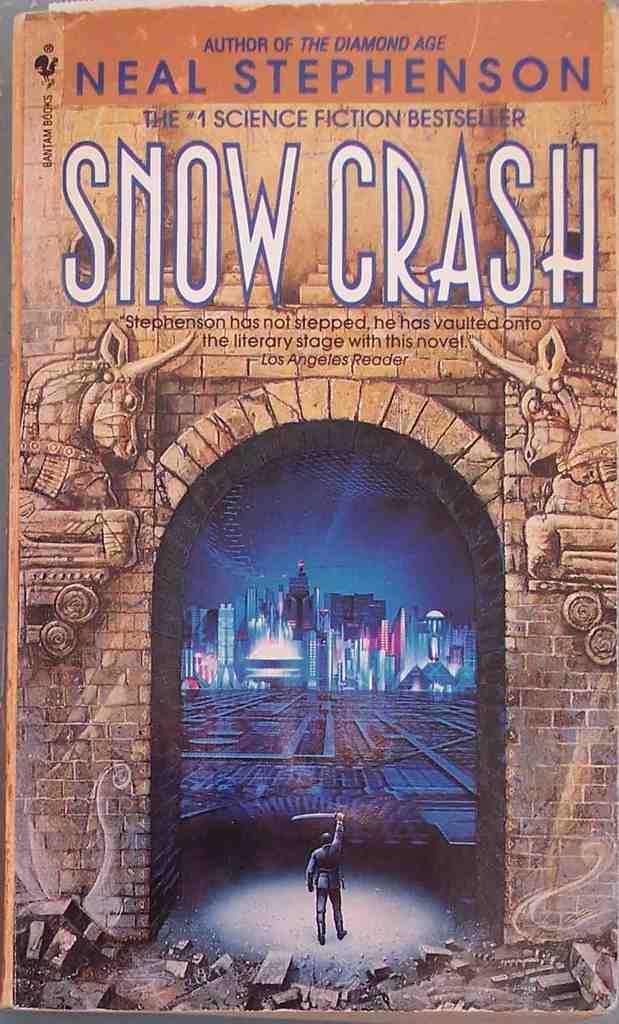Who is the author of the book ?
Your answer should be very brief. Neal stephenson. What is the book title?
Make the answer very short. Snow crash. 